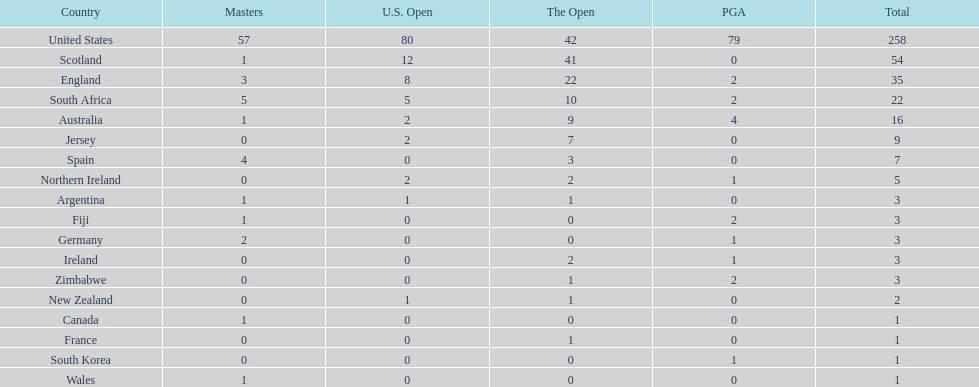In how many nations has the quantity of championship golfers been equal to that of canada? 3. 